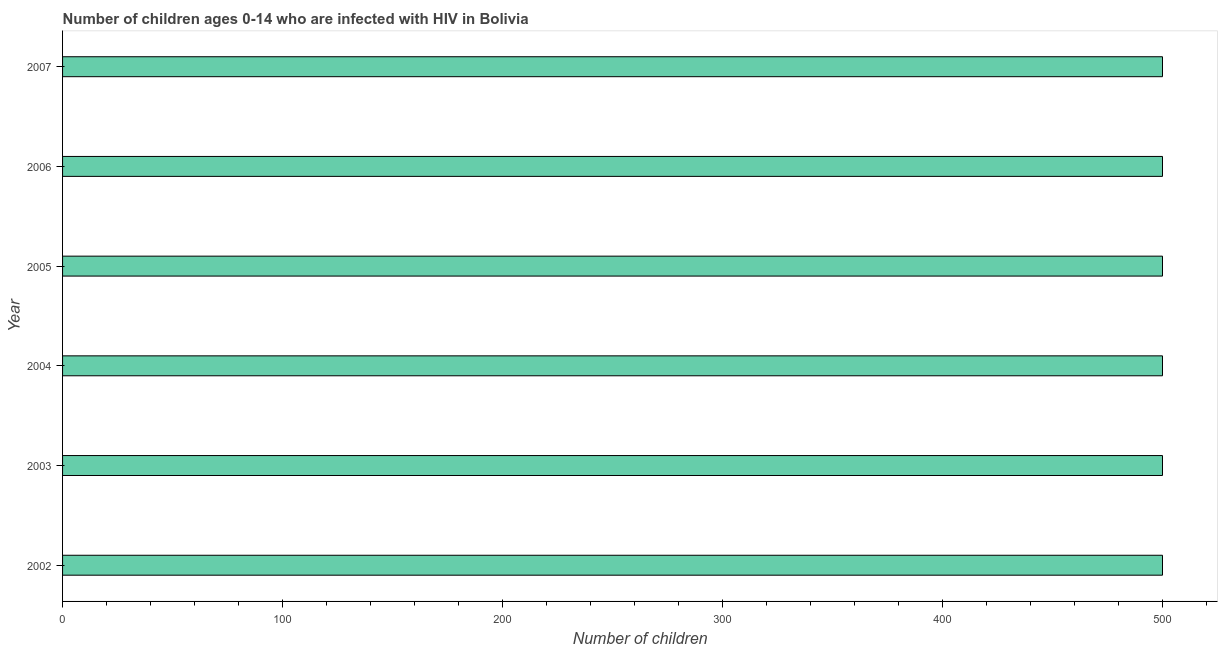What is the title of the graph?
Ensure brevity in your answer.  Number of children ages 0-14 who are infected with HIV in Bolivia. What is the label or title of the X-axis?
Your answer should be very brief. Number of children. What is the label or title of the Y-axis?
Ensure brevity in your answer.  Year. In which year was the number of children living with hiv maximum?
Your response must be concise. 2002. In which year was the number of children living with hiv minimum?
Keep it short and to the point. 2002. What is the sum of the number of children living with hiv?
Provide a succinct answer. 3000. What is the average number of children living with hiv per year?
Provide a short and direct response. 500. What is the median number of children living with hiv?
Your response must be concise. 500. In how many years, is the number of children living with hiv greater than 340 ?
Give a very brief answer. 6. Do a majority of the years between 2007 and 2004 (inclusive) have number of children living with hiv greater than 300 ?
Your answer should be very brief. Yes. What is the ratio of the number of children living with hiv in 2002 to that in 2005?
Offer a terse response. 1. Is the number of children living with hiv in 2002 less than that in 2003?
Your response must be concise. No. Is the difference between the number of children living with hiv in 2005 and 2007 greater than the difference between any two years?
Offer a terse response. Yes. Is the sum of the number of children living with hiv in 2005 and 2006 greater than the maximum number of children living with hiv across all years?
Your response must be concise. Yes. Are all the bars in the graph horizontal?
Keep it short and to the point. Yes. What is the Number of children of 2004?
Ensure brevity in your answer.  500. What is the difference between the Number of children in 2002 and 2003?
Your answer should be very brief. 0. What is the difference between the Number of children in 2002 and 2005?
Provide a succinct answer. 0. What is the difference between the Number of children in 2002 and 2006?
Your answer should be very brief. 0. What is the difference between the Number of children in 2002 and 2007?
Your answer should be compact. 0. What is the difference between the Number of children in 2003 and 2004?
Ensure brevity in your answer.  0. What is the difference between the Number of children in 2003 and 2005?
Your response must be concise. 0. What is the difference between the Number of children in 2003 and 2006?
Your answer should be very brief. 0. What is the difference between the Number of children in 2004 and 2005?
Your answer should be compact. 0. What is the difference between the Number of children in 2004 and 2006?
Provide a short and direct response. 0. What is the difference between the Number of children in 2004 and 2007?
Your answer should be very brief. 0. What is the difference between the Number of children in 2005 and 2006?
Make the answer very short. 0. What is the difference between the Number of children in 2006 and 2007?
Your response must be concise. 0. What is the ratio of the Number of children in 2002 to that in 2005?
Ensure brevity in your answer.  1. What is the ratio of the Number of children in 2003 to that in 2006?
Offer a terse response. 1. What is the ratio of the Number of children in 2005 to that in 2007?
Offer a very short reply. 1. What is the ratio of the Number of children in 2006 to that in 2007?
Make the answer very short. 1. 